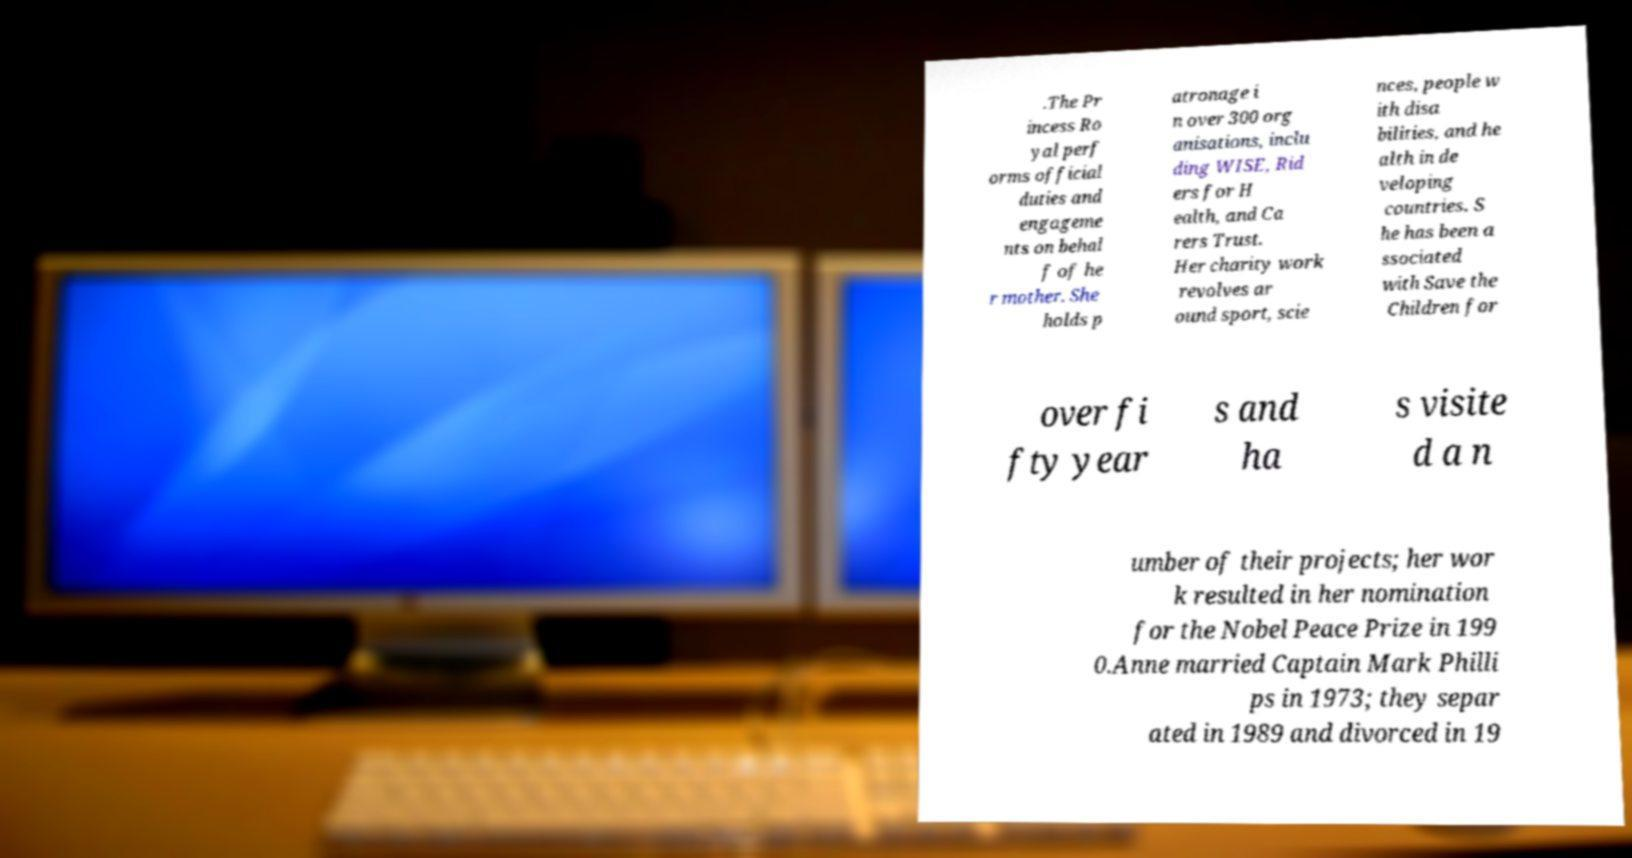There's text embedded in this image that I need extracted. Can you transcribe it verbatim? .The Pr incess Ro yal perf orms official duties and engageme nts on behal f of he r mother. She holds p atronage i n over 300 org anisations, inclu ding WISE, Rid ers for H ealth, and Ca rers Trust. Her charity work revolves ar ound sport, scie nces, people w ith disa bilities, and he alth in de veloping countries. S he has been a ssociated with Save the Children for over fi fty year s and ha s visite d a n umber of their projects; her wor k resulted in her nomination for the Nobel Peace Prize in 199 0.Anne married Captain Mark Philli ps in 1973; they separ ated in 1989 and divorced in 19 